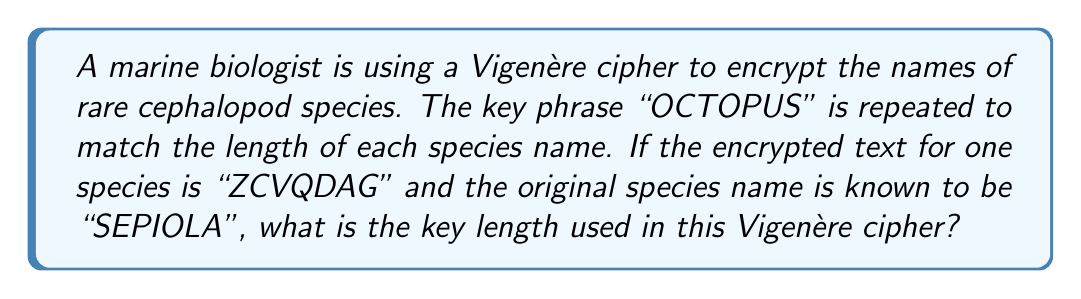Solve this math problem. To find the key length, we need to follow these steps:

1) First, recall that in a Vigenère cipher, each letter of the key is used to shift the corresponding letter of the plaintext.

2) We are given:
   Plaintext: SEPIOLA
   Ciphertext: ZCVQDAG

3) Let's align the plaintext, ciphertext, and key:

   Plaintext:  S E P I O L A
   Ciphertext: Z C V Q D A G
   Key:        ? ? ? ? ? ? ?

4) For each column, we need to find the shift that transforms the plaintext letter to the ciphertext letter. This shift corresponds to the key letter.

5) We can calculate the shift using the formula:
   $$(c - p + 26) \mod 26 = k$$
   where $c$ is the ciphertext letter, $p$ is the plaintext letter, and $k$ is the key letter (all represented as numbers from 0 to 25).

6) Let's calculate for each column:
   
   S → Z: $(25 - 18 + 26) \mod 26 = 7$ (O)
   E → C: $(2 - 4 + 26) \mod 26 = 24$ (C)
   P → V: $(21 - 15 + 26) \mod 26 = 6$ (T)
   I → Q: $(16 - 8 + 26) \mod 26 = 8$ (O)
   O → D: $(3 - 14 + 26) \mod 26 = 15$ (P)
   L → A: $(0 - 11 + 26) \mod 26 = 15$ (U)
   A → G: $(6 - 0 + 26) \mod 26 = 6$ (S)

7) This gives us the key: OCTOPUS

8) The length of this key is 7.
Answer: 7 